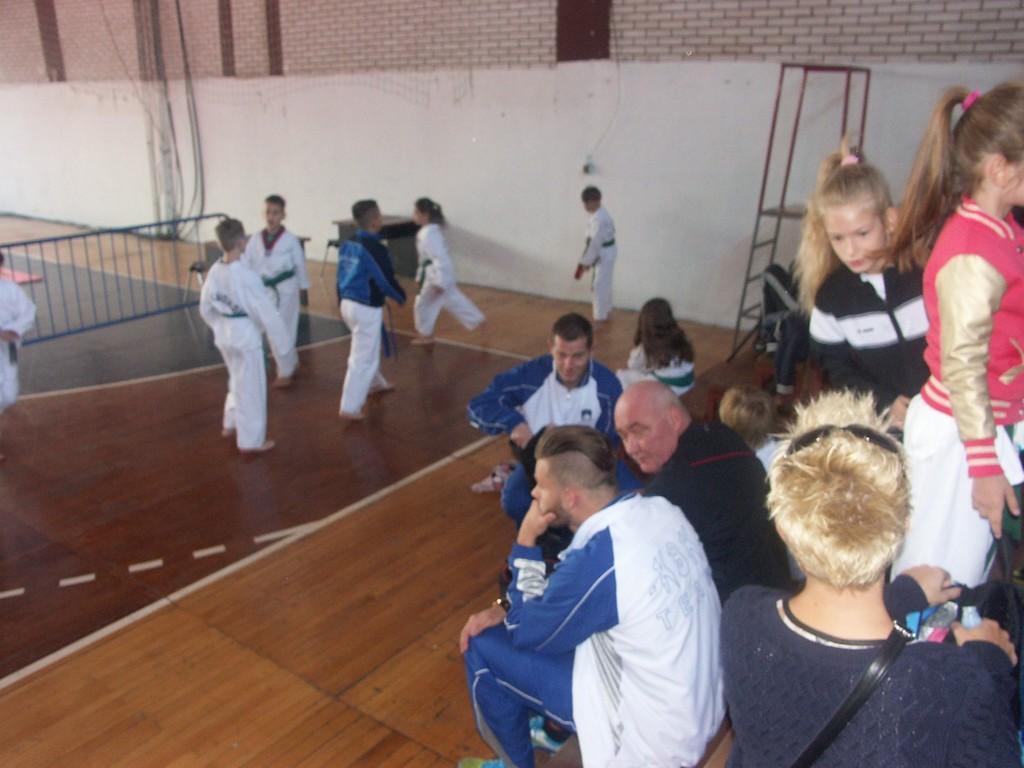Please provide a concise description of this image. In the center of the image we can see someone wearing a uniform. On the right side of the image we can see some person and some of them are sitting. In the background of the image we can see barricade, stand, wall, pipes. At the bottom of the image we can see the floor. 